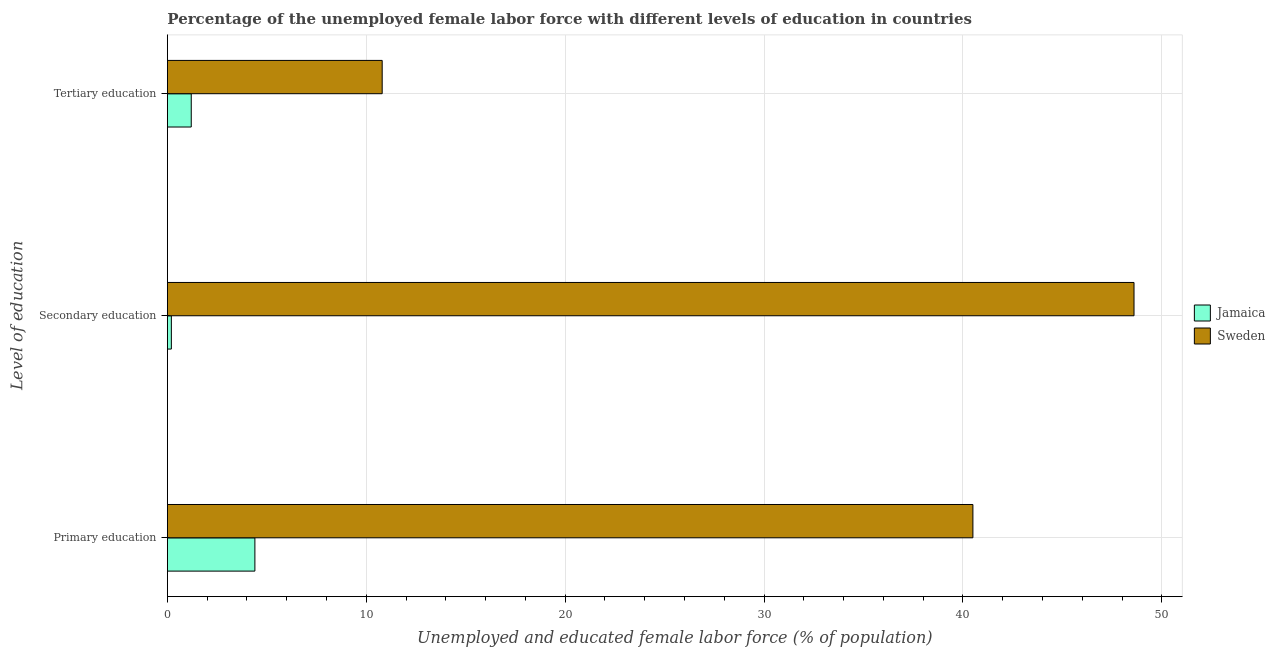How many different coloured bars are there?
Provide a succinct answer. 2. How many groups of bars are there?
Offer a terse response. 3. Are the number of bars per tick equal to the number of legend labels?
Keep it short and to the point. Yes. How many bars are there on the 2nd tick from the bottom?
Offer a terse response. 2. What is the label of the 1st group of bars from the top?
Offer a very short reply. Tertiary education. What is the percentage of female labor force who received tertiary education in Jamaica?
Offer a very short reply. 1.2. Across all countries, what is the maximum percentage of female labor force who received secondary education?
Give a very brief answer. 48.6. Across all countries, what is the minimum percentage of female labor force who received tertiary education?
Ensure brevity in your answer.  1.2. In which country was the percentage of female labor force who received secondary education maximum?
Your answer should be compact. Sweden. In which country was the percentage of female labor force who received tertiary education minimum?
Keep it short and to the point. Jamaica. What is the total percentage of female labor force who received tertiary education in the graph?
Provide a short and direct response. 12. What is the difference between the percentage of female labor force who received primary education in Sweden and that in Jamaica?
Keep it short and to the point. 36.1. What is the difference between the percentage of female labor force who received primary education in Sweden and the percentage of female labor force who received tertiary education in Jamaica?
Your response must be concise. 39.3. What is the average percentage of female labor force who received tertiary education per country?
Your answer should be very brief. 6. What is the difference between the percentage of female labor force who received tertiary education and percentage of female labor force who received secondary education in Jamaica?
Offer a terse response. 1. In how many countries, is the percentage of female labor force who received primary education greater than 44 %?
Give a very brief answer. 0. What is the ratio of the percentage of female labor force who received secondary education in Sweden to that in Jamaica?
Provide a succinct answer. 243. Is the percentage of female labor force who received primary education in Jamaica less than that in Sweden?
Keep it short and to the point. Yes. Is the difference between the percentage of female labor force who received tertiary education in Sweden and Jamaica greater than the difference between the percentage of female labor force who received secondary education in Sweden and Jamaica?
Give a very brief answer. No. What is the difference between the highest and the second highest percentage of female labor force who received primary education?
Offer a very short reply. 36.1. What is the difference between the highest and the lowest percentage of female labor force who received primary education?
Your response must be concise. 36.1. In how many countries, is the percentage of female labor force who received tertiary education greater than the average percentage of female labor force who received tertiary education taken over all countries?
Provide a short and direct response. 1. Is the sum of the percentage of female labor force who received primary education in Jamaica and Sweden greater than the maximum percentage of female labor force who received secondary education across all countries?
Ensure brevity in your answer.  No. What does the 2nd bar from the top in Tertiary education represents?
Your answer should be very brief. Jamaica. What does the 2nd bar from the bottom in Secondary education represents?
Your response must be concise. Sweden. How many bars are there?
Your answer should be compact. 6. How many countries are there in the graph?
Ensure brevity in your answer.  2. Are the values on the major ticks of X-axis written in scientific E-notation?
Your answer should be compact. No. What is the title of the graph?
Keep it short and to the point. Percentage of the unemployed female labor force with different levels of education in countries. Does "Brunei Darussalam" appear as one of the legend labels in the graph?
Ensure brevity in your answer.  No. What is the label or title of the X-axis?
Your answer should be very brief. Unemployed and educated female labor force (% of population). What is the label or title of the Y-axis?
Your response must be concise. Level of education. What is the Unemployed and educated female labor force (% of population) of Jamaica in Primary education?
Keep it short and to the point. 4.4. What is the Unemployed and educated female labor force (% of population) in Sweden in Primary education?
Provide a succinct answer. 40.5. What is the Unemployed and educated female labor force (% of population) in Jamaica in Secondary education?
Ensure brevity in your answer.  0.2. What is the Unemployed and educated female labor force (% of population) in Sweden in Secondary education?
Give a very brief answer. 48.6. What is the Unemployed and educated female labor force (% of population) of Jamaica in Tertiary education?
Make the answer very short. 1.2. What is the Unemployed and educated female labor force (% of population) in Sweden in Tertiary education?
Offer a terse response. 10.8. Across all Level of education, what is the maximum Unemployed and educated female labor force (% of population) in Jamaica?
Ensure brevity in your answer.  4.4. Across all Level of education, what is the maximum Unemployed and educated female labor force (% of population) of Sweden?
Your response must be concise. 48.6. Across all Level of education, what is the minimum Unemployed and educated female labor force (% of population) in Jamaica?
Make the answer very short. 0.2. Across all Level of education, what is the minimum Unemployed and educated female labor force (% of population) of Sweden?
Your response must be concise. 10.8. What is the total Unemployed and educated female labor force (% of population) in Sweden in the graph?
Offer a terse response. 99.9. What is the difference between the Unemployed and educated female labor force (% of population) of Sweden in Primary education and that in Secondary education?
Your answer should be compact. -8.1. What is the difference between the Unemployed and educated female labor force (% of population) in Jamaica in Primary education and that in Tertiary education?
Offer a very short reply. 3.2. What is the difference between the Unemployed and educated female labor force (% of population) in Sweden in Primary education and that in Tertiary education?
Keep it short and to the point. 29.7. What is the difference between the Unemployed and educated female labor force (% of population) of Sweden in Secondary education and that in Tertiary education?
Your answer should be compact. 37.8. What is the difference between the Unemployed and educated female labor force (% of population) in Jamaica in Primary education and the Unemployed and educated female labor force (% of population) in Sweden in Secondary education?
Your answer should be compact. -44.2. What is the difference between the Unemployed and educated female labor force (% of population) of Jamaica in Secondary education and the Unemployed and educated female labor force (% of population) of Sweden in Tertiary education?
Keep it short and to the point. -10.6. What is the average Unemployed and educated female labor force (% of population) of Jamaica per Level of education?
Your answer should be compact. 1.93. What is the average Unemployed and educated female labor force (% of population) in Sweden per Level of education?
Offer a very short reply. 33.3. What is the difference between the Unemployed and educated female labor force (% of population) of Jamaica and Unemployed and educated female labor force (% of population) of Sweden in Primary education?
Offer a terse response. -36.1. What is the difference between the Unemployed and educated female labor force (% of population) in Jamaica and Unemployed and educated female labor force (% of population) in Sweden in Secondary education?
Your response must be concise. -48.4. What is the ratio of the Unemployed and educated female labor force (% of population) in Jamaica in Primary education to that in Secondary education?
Offer a very short reply. 22. What is the ratio of the Unemployed and educated female labor force (% of population) in Sweden in Primary education to that in Secondary education?
Provide a succinct answer. 0.83. What is the ratio of the Unemployed and educated female labor force (% of population) of Jamaica in Primary education to that in Tertiary education?
Give a very brief answer. 3.67. What is the ratio of the Unemployed and educated female labor force (% of population) of Sweden in Primary education to that in Tertiary education?
Your response must be concise. 3.75. What is the ratio of the Unemployed and educated female labor force (% of population) of Jamaica in Secondary education to that in Tertiary education?
Provide a short and direct response. 0.17. What is the ratio of the Unemployed and educated female labor force (% of population) in Sweden in Secondary education to that in Tertiary education?
Make the answer very short. 4.5. What is the difference between the highest and the second highest Unemployed and educated female labor force (% of population) of Jamaica?
Provide a succinct answer. 3.2. What is the difference between the highest and the second highest Unemployed and educated female labor force (% of population) of Sweden?
Your response must be concise. 8.1. What is the difference between the highest and the lowest Unemployed and educated female labor force (% of population) in Jamaica?
Provide a succinct answer. 4.2. What is the difference between the highest and the lowest Unemployed and educated female labor force (% of population) in Sweden?
Your answer should be compact. 37.8. 